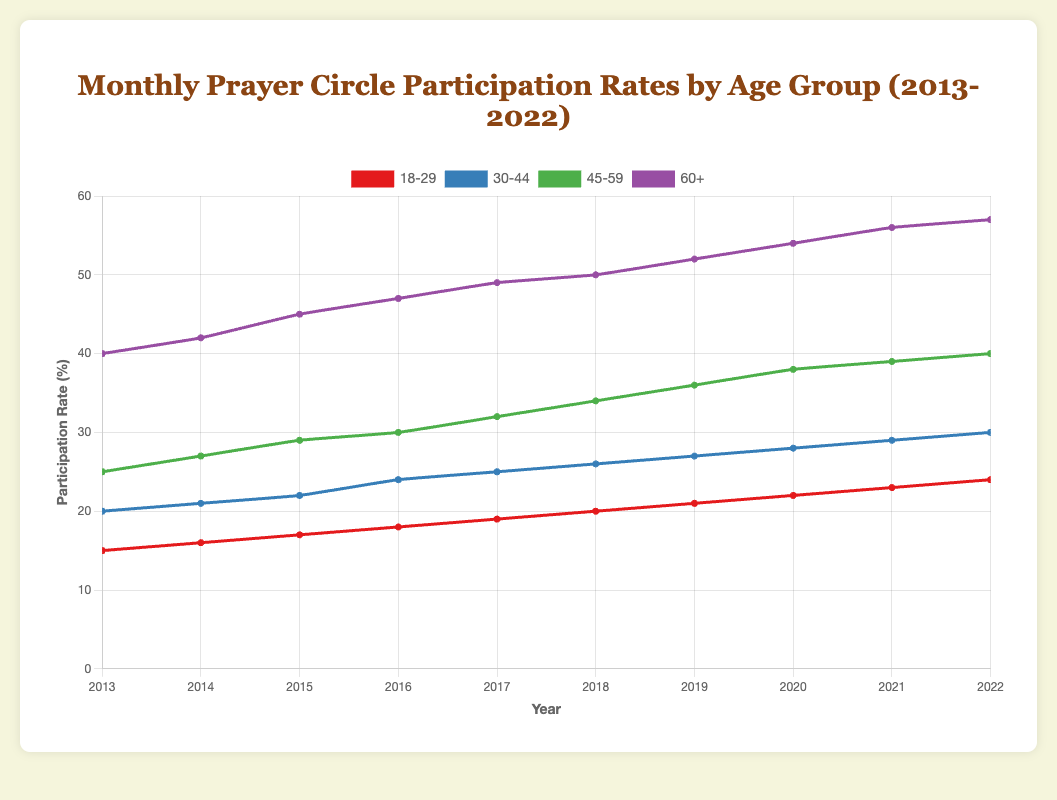What is the highest participation rate in any age group over the last decade? The highest participation rate can be found by observing the y-axis values for all age groups. The 60+ age group has the highest rate at 57% in 2022.
Answer: 57% Which age group had a steady increase in participation rate over the years? By observing the trend lines, the 18-29 age group shows a consistent increase in participation rate from 15% in 2013 to 24% in 2022.
Answer: 18-29 In which year did the 30-44 age group first reach a participation rate of 25%? By following the 30-44 age group's line on the chart and checking the x-axis values, it first reached a 25% participation rate in 2017.
Answer: 2017 Calculate the average participation rate of the 45-59 age group from 2013 to 2022. Summing the participation rates for the 45-59 age group from 2013 to 2022 (25+27+29+30+32+34+36+38+39+40) = 330, then dividing by the number of years (10) gives an average of 33%.
Answer: 33% Which age group saw the largest increase in participation rate from 2013 to 2022? By calculating the difference in participation rates between 2013 and 2022 for each age group: 
- 18-29: 24% - 15% = 9%
- 30-44: 30% - 20% = 10%
- 45-59: 40% - 25% = 15%
- 60+: 57% - 40% = 17%
The 60+ age group had the largest increase of 17%.
Answer: 60+ Which two age groups had the closest participation rates in the year 2018? By examining the lines for 2018, the participation rates for the 18-29 (20%) and 30-44 (26%) groups differ by 6%, whereas the 45-59 (34%) and 60+ (50%) groups differ by 16%. The 18-29 and 30-44 groups had the closest rates.
Answer: 18-29 and 30-44 What is the participation rate trend for the 60+ age group over the decade? Observing the 60+ age group's line reveals a consistently upward trend in participation rates, increasing from 40% in 2013 to 57% in 2022.
Answer: Increasing By how much did the participation rate of the 45-59 age group change from 2019 to 2021? The participation rate for the 45-59 age group in 2019 was 36%. In 2021, it was 39%. The change is 39% - 36% = 3%.
Answer: 3% In which year did the 18-29 age group participation rate equal the 30-44 age group's rate from 2013? The 18-29 age group reached a participation rate of 20% in 2018, which matches the 30-44 age group's rate in 2013.
Answer: 2018 